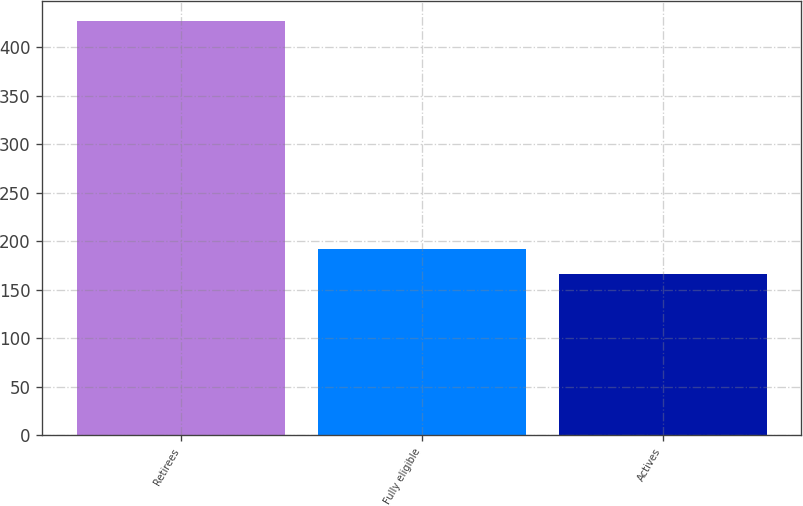<chart> <loc_0><loc_0><loc_500><loc_500><bar_chart><fcel>Retirees<fcel>Fully eligible<fcel>Actives<nl><fcel>427<fcel>192.1<fcel>166<nl></chart> 